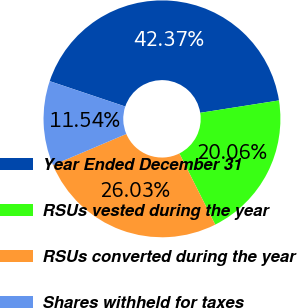Convert chart to OTSL. <chart><loc_0><loc_0><loc_500><loc_500><pie_chart><fcel>Year Ended December 31<fcel>RSUs vested during the year<fcel>RSUs converted during the year<fcel>Shares withheld for taxes<nl><fcel>42.37%<fcel>20.06%<fcel>26.03%<fcel>11.54%<nl></chart> 